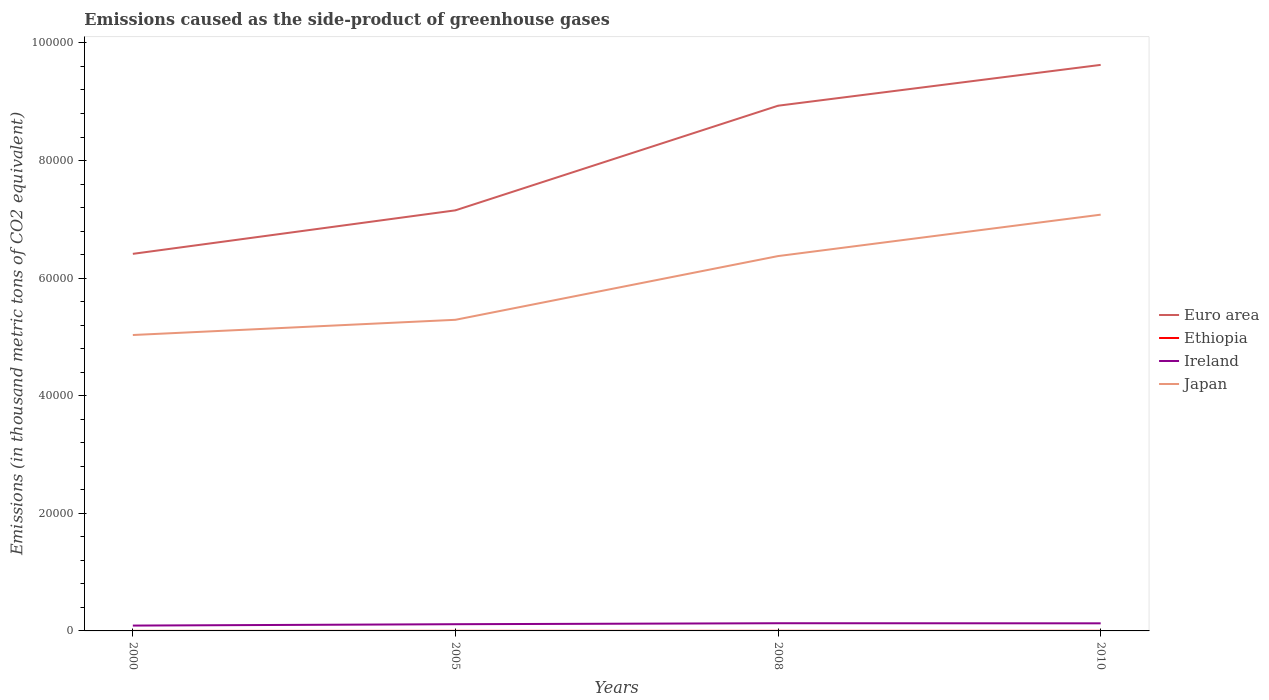How many different coloured lines are there?
Provide a short and direct response. 4. Does the line corresponding to Ethiopia intersect with the line corresponding to Euro area?
Ensure brevity in your answer.  No. Is the number of lines equal to the number of legend labels?
Your answer should be compact. Yes. Across all years, what is the maximum emissions caused as the side-product of greenhouse gases in Euro area?
Ensure brevity in your answer.  6.41e+04. What is the total emissions caused as the side-product of greenhouse gases in Ethiopia in the graph?
Provide a short and direct response. -2.7. Is the emissions caused as the side-product of greenhouse gases in Japan strictly greater than the emissions caused as the side-product of greenhouse gases in Ethiopia over the years?
Offer a terse response. No. How many lines are there?
Your response must be concise. 4. How many years are there in the graph?
Keep it short and to the point. 4. Does the graph contain grids?
Offer a very short reply. No. Where does the legend appear in the graph?
Offer a terse response. Center right. How many legend labels are there?
Make the answer very short. 4. What is the title of the graph?
Keep it short and to the point. Emissions caused as the side-product of greenhouse gases. What is the label or title of the Y-axis?
Provide a succinct answer. Emissions (in thousand metric tons of CO2 equivalent). What is the Emissions (in thousand metric tons of CO2 equivalent) in Euro area in 2000?
Offer a very short reply. 6.41e+04. What is the Emissions (in thousand metric tons of CO2 equivalent) in Ethiopia in 2000?
Make the answer very short. 3.6. What is the Emissions (in thousand metric tons of CO2 equivalent) in Ireland in 2000?
Give a very brief answer. 908.4. What is the Emissions (in thousand metric tons of CO2 equivalent) in Japan in 2000?
Offer a terse response. 5.03e+04. What is the Emissions (in thousand metric tons of CO2 equivalent) of Euro area in 2005?
Ensure brevity in your answer.  7.15e+04. What is the Emissions (in thousand metric tons of CO2 equivalent) in Ethiopia in 2005?
Provide a succinct answer. 10.3. What is the Emissions (in thousand metric tons of CO2 equivalent) of Ireland in 2005?
Keep it short and to the point. 1143.3. What is the Emissions (in thousand metric tons of CO2 equivalent) in Japan in 2005?
Make the answer very short. 5.29e+04. What is the Emissions (in thousand metric tons of CO2 equivalent) of Euro area in 2008?
Your answer should be very brief. 8.93e+04. What is the Emissions (in thousand metric tons of CO2 equivalent) in Ireland in 2008?
Your answer should be compact. 1306.1. What is the Emissions (in thousand metric tons of CO2 equivalent) of Japan in 2008?
Provide a short and direct response. 6.38e+04. What is the Emissions (in thousand metric tons of CO2 equivalent) of Euro area in 2010?
Your answer should be compact. 9.63e+04. What is the Emissions (in thousand metric tons of CO2 equivalent) of Ethiopia in 2010?
Offer a terse response. 16. What is the Emissions (in thousand metric tons of CO2 equivalent) of Ireland in 2010?
Keep it short and to the point. 1291. What is the Emissions (in thousand metric tons of CO2 equivalent) in Japan in 2010?
Ensure brevity in your answer.  7.08e+04. Across all years, what is the maximum Emissions (in thousand metric tons of CO2 equivalent) in Euro area?
Provide a short and direct response. 9.63e+04. Across all years, what is the maximum Emissions (in thousand metric tons of CO2 equivalent) in Ethiopia?
Offer a very short reply. 16. Across all years, what is the maximum Emissions (in thousand metric tons of CO2 equivalent) in Ireland?
Provide a short and direct response. 1306.1. Across all years, what is the maximum Emissions (in thousand metric tons of CO2 equivalent) of Japan?
Provide a succinct answer. 7.08e+04. Across all years, what is the minimum Emissions (in thousand metric tons of CO2 equivalent) of Euro area?
Provide a short and direct response. 6.41e+04. Across all years, what is the minimum Emissions (in thousand metric tons of CO2 equivalent) of Ireland?
Provide a short and direct response. 908.4. Across all years, what is the minimum Emissions (in thousand metric tons of CO2 equivalent) in Japan?
Offer a terse response. 5.03e+04. What is the total Emissions (in thousand metric tons of CO2 equivalent) of Euro area in the graph?
Offer a very short reply. 3.21e+05. What is the total Emissions (in thousand metric tons of CO2 equivalent) of Ethiopia in the graph?
Your answer should be compact. 43.2. What is the total Emissions (in thousand metric tons of CO2 equivalent) in Ireland in the graph?
Ensure brevity in your answer.  4648.8. What is the total Emissions (in thousand metric tons of CO2 equivalent) of Japan in the graph?
Ensure brevity in your answer.  2.38e+05. What is the difference between the Emissions (in thousand metric tons of CO2 equivalent) of Euro area in 2000 and that in 2005?
Provide a succinct answer. -7401.3. What is the difference between the Emissions (in thousand metric tons of CO2 equivalent) in Ireland in 2000 and that in 2005?
Your response must be concise. -234.9. What is the difference between the Emissions (in thousand metric tons of CO2 equivalent) in Japan in 2000 and that in 2005?
Provide a short and direct response. -2588.2. What is the difference between the Emissions (in thousand metric tons of CO2 equivalent) of Euro area in 2000 and that in 2008?
Give a very brief answer. -2.52e+04. What is the difference between the Emissions (in thousand metric tons of CO2 equivalent) of Ireland in 2000 and that in 2008?
Offer a very short reply. -397.7. What is the difference between the Emissions (in thousand metric tons of CO2 equivalent) of Japan in 2000 and that in 2008?
Your answer should be compact. -1.34e+04. What is the difference between the Emissions (in thousand metric tons of CO2 equivalent) of Euro area in 2000 and that in 2010?
Make the answer very short. -3.21e+04. What is the difference between the Emissions (in thousand metric tons of CO2 equivalent) of Ireland in 2000 and that in 2010?
Your answer should be very brief. -382.6. What is the difference between the Emissions (in thousand metric tons of CO2 equivalent) in Japan in 2000 and that in 2010?
Your response must be concise. -2.05e+04. What is the difference between the Emissions (in thousand metric tons of CO2 equivalent) of Euro area in 2005 and that in 2008?
Your answer should be compact. -1.78e+04. What is the difference between the Emissions (in thousand metric tons of CO2 equivalent) in Ireland in 2005 and that in 2008?
Offer a terse response. -162.8. What is the difference between the Emissions (in thousand metric tons of CO2 equivalent) of Japan in 2005 and that in 2008?
Provide a short and direct response. -1.08e+04. What is the difference between the Emissions (in thousand metric tons of CO2 equivalent) of Euro area in 2005 and that in 2010?
Your answer should be very brief. -2.47e+04. What is the difference between the Emissions (in thousand metric tons of CO2 equivalent) of Ethiopia in 2005 and that in 2010?
Offer a terse response. -5.7. What is the difference between the Emissions (in thousand metric tons of CO2 equivalent) of Ireland in 2005 and that in 2010?
Ensure brevity in your answer.  -147.7. What is the difference between the Emissions (in thousand metric tons of CO2 equivalent) in Japan in 2005 and that in 2010?
Your answer should be very brief. -1.79e+04. What is the difference between the Emissions (in thousand metric tons of CO2 equivalent) in Euro area in 2008 and that in 2010?
Provide a succinct answer. -6944.7. What is the difference between the Emissions (in thousand metric tons of CO2 equivalent) of Japan in 2008 and that in 2010?
Ensure brevity in your answer.  -7042.3. What is the difference between the Emissions (in thousand metric tons of CO2 equivalent) in Euro area in 2000 and the Emissions (in thousand metric tons of CO2 equivalent) in Ethiopia in 2005?
Give a very brief answer. 6.41e+04. What is the difference between the Emissions (in thousand metric tons of CO2 equivalent) in Euro area in 2000 and the Emissions (in thousand metric tons of CO2 equivalent) in Ireland in 2005?
Offer a very short reply. 6.30e+04. What is the difference between the Emissions (in thousand metric tons of CO2 equivalent) in Euro area in 2000 and the Emissions (in thousand metric tons of CO2 equivalent) in Japan in 2005?
Provide a succinct answer. 1.12e+04. What is the difference between the Emissions (in thousand metric tons of CO2 equivalent) of Ethiopia in 2000 and the Emissions (in thousand metric tons of CO2 equivalent) of Ireland in 2005?
Offer a very short reply. -1139.7. What is the difference between the Emissions (in thousand metric tons of CO2 equivalent) of Ethiopia in 2000 and the Emissions (in thousand metric tons of CO2 equivalent) of Japan in 2005?
Give a very brief answer. -5.29e+04. What is the difference between the Emissions (in thousand metric tons of CO2 equivalent) in Ireland in 2000 and the Emissions (in thousand metric tons of CO2 equivalent) in Japan in 2005?
Offer a terse response. -5.20e+04. What is the difference between the Emissions (in thousand metric tons of CO2 equivalent) of Euro area in 2000 and the Emissions (in thousand metric tons of CO2 equivalent) of Ethiopia in 2008?
Provide a short and direct response. 6.41e+04. What is the difference between the Emissions (in thousand metric tons of CO2 equivalent) in Euro area in 2000 and the Emissions (in thousand metric tons of CO2 equivalent) in Ireland in 2008?
Your answer should be compact. 6.28e+04. What is the difference between the Emissions (in thousand metric tons of CO2 equivalent) of Euro area in 2000 and the Emissions (in thousand metric tons of CO2 equivalent) of Japan in 2008?
Provide a succinct answer. 379.1. What is the difference between the Emissions (in thousand metric tons of CO2 equivalent) in Ethiopia in 2000 and the Emissions (in thousand metric tons of CO2 equivalent) in Ireland in 2008?
Your answer should be compact. -1302.5. What is the difference between the Emissions (in thousand metric tons of CO2 equivalent) in Ethiopia in 2000 and the Emissions (in thousand metric tons of CO2 equivalent) in Japan in 2008?
Your response must be concise. -6.37e+04. What is the difference between the Emissions (in thousand metric tons of CO2 equivalent) of Ireland in 2000 and the Emissions (in thousand metric tons of CO2 equivalent) of Japan in 2008?
Offer a terse response. -6.28e+04. What is the difference between the Emissions (in thousand metric tons of CO2 equivalent) in Euro area in 2000 and the Emissions (in thousand metric tons of CO2 equivalent) in Ethiopia in 2010?
Your response must be concise. 6.41e+04. What is the difference between the Emissions (in thousand metric tons of CO2 equivalent) in Euro area in 2000 and the Emissions (in thousand metric tons of CO2 equivalent) in Ireland in 2010?
Provide a short and direct response. 6.28e+04. What is the difference between the Emissions (in thousand metric tons of CO2 equivalent) in Euro area in 2000 and the Emissions (in thousand metric tons of CO2 equivalent) in Japan in 2010?
Give a very brief answer. -6663.2. What is the difference between the Emissions (in thousand metric tons of CO2 equivalent) in Ethiopia in 2000 and the Emissions (in thousand metric tons of CO2 equivalent) in Ireland in 2010?
Keep it short and to the point. -1287.4. What is the difference between the Emissions (in thousand metric tons of CO2 equivalent) in Ethiopia in 2000 and the Emissions (in thousand metric tons of CO2 equivalent) in Japan in 2010?
Provide a succinct answer. -7.08e+04. What is the difference between the Emissions (in thousand metric tons of CO2 equivalent) of Ireland in 2000 and the Emissions (in thousand metric tons of CO2 equivalent) of Japan in 2010?
Your answer should be very brief. -6.99e+04. What is the difference between the Emissions (in thousand metric tons of CO2 equivalent) of Euro area in 2005 and the Emissions (in thousand metric tons of CO2 equivalent) of Ethiopia in 2008?
Make the answer very short. 7.15e+04. What is the difference between the Emissions (in thousand metric tons of CO2 equivalent) of Euro area in 2005 and the Emissions (in thousand metric tons of CO2 equivalent) of Ireland in 2008?
Provide a succinct answer. 7.02e+04. What is the difference between the Emissions (in thousand metric tons of CO2 equivalent) of Euro area in 2005 and the Emissions (in thousand metric tons of CO2 equivalent) of Japan in 2008?
Provide a succinct answer. 7780.4. What is the difference between the Emissions (in thousand metric tons of CO2 equivalent) in Ethiopia in 2005 and the Emissions (in thousand metric tons of CO2 equivalent) in Ireland in 2008?
Give a very brief answer. -1295.8. What is the difference between the Emissions (in thousand metric tons of CO2 equivalent) of Ethiopia in 2005 and the Emissions (in thousand metric tons of CO2 equivalent) of Japan in 2008?
Keep it short and to the point. -6.37e+04. What is the difference between the Emissions (in thousand metric tons of CO2 equivalent) of Ireland in 2005 and the Emissions (in thousand metric tons of CO2 equivalent) of Japan in 2008?
Your answer should be compact. -6.26e+04. What is the difference between the Emissions (in thousand metric tons of CO2 equivalent) of Euro area in 2005 and the Emissions (in thousand metric tons of CO2 equivalent) of Ethiopia in 2010?
Ensure brevity in your answer.  7.15e+04. What is the difference between the Emissions (in thousand metric tons of CO2 equivalent) of Euro area in 2005 and the Emissions (in thousand metric tons of CO2 equivalent) of Ireland in 2010?
Provide a short and direct response. 7.02e+04. What is the difference between the Emissions (in thousand metric tons of CO2 equivalent) of Euro area in 2005 and the Emissions (in thousand metric tons of CO2 equivalent) of Japan in 2010?
Keep it short and to the point. 738.1. What is the difference between the Emissions (in thousand metric tons of CO2 equivalent) in Ethiopia in 2005 and the Emissions (in thousand metric tons of CO2 equivalent) in Ireland in 2010?
Offer a terse response. -1280.7. What is the difference between the Emissions (in thousand metric tons of CO2 equivalent) of Ethiopia in 2005 and the Emissions (in thousand metric tons of CO2 equivalent) of Japan in 2010?
Keep it short and to the point. -7.08e+04. What is the difference between the Emissions (in thousand metric tons of CO2 equivalent) in Ireland in 2005 and the Emissions (in thousand metric tons of CO2 equivalent) in Japan in 2010?
Give a very brief answer. -6.96e+04. What is the difference between the Emissions (in thousand metric tons of CO2 equivalent) of Euro area in 2008 and the Emissions (in thousand metric tons of CO2 equivalent) of Ethiopia in 2010?
Offer a very short reply. 8.93e+04. What is the difference between the Emissions (in thousand metric tons of CO2 equivalent) of Euro area in 2008 and the Emissions (in thousand metric tons of CO2 equivalent) of Ireland in 2010?
Provide a succinct answer. 8.80e+04. What is the difference between the Emissions (in thousand metric tons of CO2 equivalent) of Euro area in 2008 and the Emissions (in thousand metric tons of CO2 equivalent) of Japan in 2010?
Offer a very short reply. 1.85e+04. What is the difference between the Emissions (in thousand metric tons of CO2 equivalent) of Ethiopia in 2008 and the Emissions (in thousand metric tons of CO2 equivalent) of Ireland in 2010?
Give a very brief answer. -1277.7. What is the difference between the Emissions (in thousand metric tons of CO2 equivalent) in Ethiopia in 2008 and the Emissions (in thousand metric tons of CO2 equivalent) in Japan in 2010?
Your answer should be very brief. -7.08e+04. What is the difference between the Emissions (in thousand metric tons of CO2 equivalent) of Ireland in 2008 and the Emissions (in thousand metric tons of CO2 equivalent) of Japan in 2010?
Your response must be concise. -6.95e+04. What is the average Emissions (in thousand metric tons of CO2 equivalent) of Euro area per year?
Offer a very short reply. 8.03e+04. What is the average Emissions (in thousand metric tons of CO2 equivalent) of Ireland per year?
Provide a short and direct response. 1162.2. What is the average Emissions (in thousand metric tons of CO2 equivalent) in Japan per year?
Make the answer very short. 5.94e+04. In the year 2000, what is the difference between the Emissions (in thousand metric tons of CO2 equivalent) in Euro area and Emissions (in thousand metric tons of CO2 equivalent) in Ethiopia?
Offer a very short reply. 6.41e+04. In the year 2000, what is the difference between the Emissions (in thousand metric tons of CO2 equivalent) of Euro area and Emissions (in thousand metric tons of CO2 equivalent) of Ireland?
Your answer should be compact. 6.32e+04. In the year 2000, what is the difference between the Emissions (in thousand metric tons of CO2 equivalent) in Euro area and Emissions (in thousand metric tons of CO2 equivalent) in Japan?
Your answer should be very brief. 1.38e+04. In the year 2000, what is the difference between the Emissions (in thousand metric tons of CO2 equivalent) of Ethiopia and Emissions (in thousand metric tons of CO2 equivalent) of Ireland?
Your response must be concise. -904.8. In the year 2000, what is the difference between the Emissions (in thousand metric tons of CO2 equivalent) of Ethiopia and Emissions (in thousand metric tons of CO2 equivalent) of Japan?
Make the answer very short. -5.03e+04. In the year 2000, what is the difference between the Emissions (in thousand metric tons of CO2 equivalent) in Ireland and Emissions (in thousand metric tons of CO2 equivalent) in Japan?
Your answer should be very brief. -4.94e+04. In the year 2005, what is the difference between the Emissions (in thousand metric tons of CO2 equivalent) in Euro area and Emissions (in thousand metric tons of CO2 equivalent) in Ethiopia?
Offer a terse response. 7.15e+04. In the year 2005, what is the difference between the Emissions (in thousand metric tons of CO2 equivalent) in Euro area and Emissions (in thousand metric tons of CO2 equivalent) in Ireland?
Make the answer very short. 7.04e+04. In the year 2005, what is the difference between the Emissions (in thousand metric tons of CO2 equivalent) in Euro area and Emissions (in thousand metric tons of CO2 equivalent) in Japan?
Provide a succinct answer. 1.86e+04. In the year 2005, what is the difference between the Emissions (in thousand metric tons of CO2 equivalent) of Ethiopia and Emissions (in thousand metric tons of CO2 equivalent) of Ireland?
Provide a short and direct response. -1133. In the year 2005, what is the difference between the Emissions (in thousand metric tons of CO2 equivalent) of Ethiopia and Emissions (in thousand metric tons of CO2 equivalent) of Japan?
Ensure brevity in your answer.  -5.29e+04. In the year 2005, what is the difference between the Emissions (in thousand metric tons of CO2 equivalent) of Ireland and Emissions (in thousand metric tons of CO2 equivalent) of Japan?
Your response must be concise. -5.18e+04. In the year 2008, what is the difference between the Emissions (in thousand metric tons of CO2 equivalent) of Euro area and Emissions (in thousand metric tons of CO2 equivalent) of Ethiopia?
Ensure brevity in your answer.  8.93e+04. In the year 2008, what is the difference between the Emissions (in thousand metric tons of CO2 equivalent) of Euro area and Emissions (in thousand metric tons of CO2 equivalent) of Ireland?
Provide a short and direct response. 8.80e+04. In the year 2008, what is the difference between the Emissions (in thousand metric tons of CO2 equivalent) in Euro area and Emissions (in thousand metric tons of CO2 equivalent) in Japan?
Make the answer very short. 2.56e+04. In the year 2008, what is the difference between the Emissions (in thousand metric tons of CO2 equivalent) in Ethiopia and Emissions (in thousand metric tons of CO2 equivalent) in Ireland?
Provide a short and direct response. -1292.8. In the year 2008, what is the difference between the Emissions (in thousand metric tons of CO2 equivalent) of Ethiopia and Emissions (in thousand metric tons of CO2 equivalent) of Japan?
Your answer should be compact. -6.37e+04. In the year 2008, what is the difference between the Emissions (in thousand metric tons of CO2 equivalent) of Ireland and Emissions (in thousand metric tons of CO2 equivalent) of Japan?
Provide a short and direct response. -6.24e+04. In the year 2010, what is the difference between the Emissions (in thousand metric tons of CO2 equivalent) of Euro area and Emissions (in thousand metric tons of CO2 equivalent) of Ethiopia?
Your answer should be compact. 9.63e+04. In the year 2010, what is the difference between the Emissions (in thousand metric tons of CO2 equivalent) of Euro area and Emissions (in thousand metric tons of CO2 equivalent) of Ireland?
Make the answer very short. 9.50e+04. In the year 2010, what is the difference between the Emissions (in thousand metric tons of CO2 equivalent) of Euro area and Emissions (in thousand metric tons of CO2 equivalent) of Japan?
Offer a terse response. 2.55e+04. In the year 2010, what is the difference between the Emissions (in thousand metric tons of CO2 equivalent) in Ethiopia and Emissions (in thousand metric tons of CO2 equivalent) in Ireland?
Your response must be concise. -1275. In the year 2010, what is the difference between the Emissions (in thousand metric tons of CO2 equivalent) in Ethiopia and Emissions (in thousand metric tons of CO2 equivalent) in Japan?
Keep it short and to the point. -7.08e+04. In the year 2010, what is the difference between the Emissions (in thousand metric tons of CO2 equivalent) in Ireland and Emissions (in thousand metric tons of CO2 equivalent) in Japan?
Offer a terse response. -6.95e+04. What is the ratio of the Emissions (in thousand metric tons of CO2 equivalent) of Euro area in 2000 to that in 2005?
Your response must be concise. 0.9. What is the ratio of the Emissions (in thousand metric tons of CO2 equivalent) of Ethiopia in 2000 to that in 2005?
Offer a terse response. 0.35. What is the ratio of the Emissions (in thousand metric tons of CO2 equivalent) in Ireland in 2000 to that in 2005?
Your answer should be very brief. 0.79. What is the ratio of the Emissions (in thousand metric tons of CO2 equivalent) in Japan in 2000 to that in 2005?
Keep it short and to the point. 0.95. What is the ratio of the Emissions (in thousand metric tons of CO2 equivalent) of Euro area in 2000 to that in 2008?
Offer a very short reply. 0.72. What is the ratio of the Emissions (in thousand metric tons of CO2 equivalent) in Ethiopia in 2000 to that in 2008?
Make the answer very short. 0.27. What is the ratio of the Emissions (in thousand metric tons of CO2 equivalent) of Ireland in 2000 to that in 2008?
Make the answer very short. 0.7. What is the ratio of the Emissions (in thousand metric tons of CO2 equivalent) of Japan in 2000 to that in 2008?
Provide a succinct answer. 0.79. What is the ratio of the Emissions (in thousand metric tons of CO2 equivalent) in Euro area in 2000 to that in 2010?
Your answer should be very brief. 0.67. What is the ratio of the Emissions (in thousand metric tons of CO2 equivalent) of Ethiopia in 2000 to that in 2010?
Give a very brief answer. 0.23. What is the ratio of the Emissions (in thousand metric tons of CO2 equivalent) in Ireland in 2000 to that in 2010?
Provide a succinct answer. 0.7. What is the ratio of the Emissions (in thousand metric tons of CO2 equivalent) in Japan in 2000 to that in 2010?
Give a very brief answer. 0.71. What is the ratio of the Emissions (in thousand metric tons of CO2 equivalent) of Euro area in 2005 to that in 2008?
Keep it short and to the point. 0.8. What is the ratio of the Emissions (in thousand metric tons of CO2 equivalent) of Ethiopia in 2005 to that in 2008?
Offer a very short reply. 0.77. What is the ratio of the Emissions (in thousand metric tons of CO2 equivalent) of Ireland in 2005 to that in 2008?
Keep it short and to the point. 0.88. What is the ratio of the Emissions (in thousand metric tons of CO2 equivalent) of Japan in 2005 to that in 2008?
Offer a very short reply. 0.83. What is the ratio of the Emissions (in thousand metric tons of CO2 equivalent) in Euro area in 2005 to that in 2010?
Your response must be concise. 0.74. What is the ratio of the Emissions (in thousand metric tons of CO2 equivalent) of Ethiopia in 2005 to that in 2010?
Offer a terse response. 0.64. What is the ratio of the Emissions (in thousand metric tons of CO2 equivalent) in Ireland in 2005 to that in 2010?
Offer a very short reply. 0.89. What is the ratio of the Emissions (in thousand metric tons of CO2 equivalent) in Japan in 2005 to that in 2010?
Provide a succinct answer. 0.75. What is the ratio of the Emissions (in thousand metric tons of CO2 equivalent) in Euro area in 2008 to that in 2010?
Provide a succinct answer. 0.93. What is the ratio of the Emissions (in thousand metric tons of CO2 equivalent) in Ethiopia in 2008 to that in 2010?
Your response must be concise. 0.83. What is the ratio of the Emissions (in thousand metric tons of CO2 equivalent) in Ireland in 2008 to that in 2010?
Provide a succinct answer. 1.01. What is the ratio of the Emissions (in thousand metric tons of CO2 equivalent) of Japan in 2008 to that in 2010?
Ensure brevity in your answer.  0.9. What is the difference between the highest and the second highest Emissions (in thousand metric tons of CO2 equivalent) of Euro area?
Provide a succinct answer. 6944.7. What is the difference between the highest and the second highest Emissions (in thousand metric tons of CO2 equivalent) in Ireland?
Your answer should be very brief. 15.1. What is the difference between the highest and the second highest Emissions (in thousand metric tons of CO2 equivalent) of Japan?
Keep it short and to the point. 7042.3. What is the difference between the highest and the lowest Emissions (in thousand metric tons of CO2 equivalent) of Euro area?
Offer a terse response. 3.21e+04. What is the difference between the highest and the lowest Emissions (in thousand metric tons of CO2 equivalent) of Ethiopia?
Your answer should be very brief. 12.4. What is the difference between the highest and the lowest Emissions (in thousand metric tons of CO2 equivalent) of Ireland?
Ensure brevity in your answer.  397.7. What is the difference between the highest and the lowest Emissions (in thousand metric tons of CO2 equivalent) of Japan?
Provide a succinct answer. 2.05e+04. 